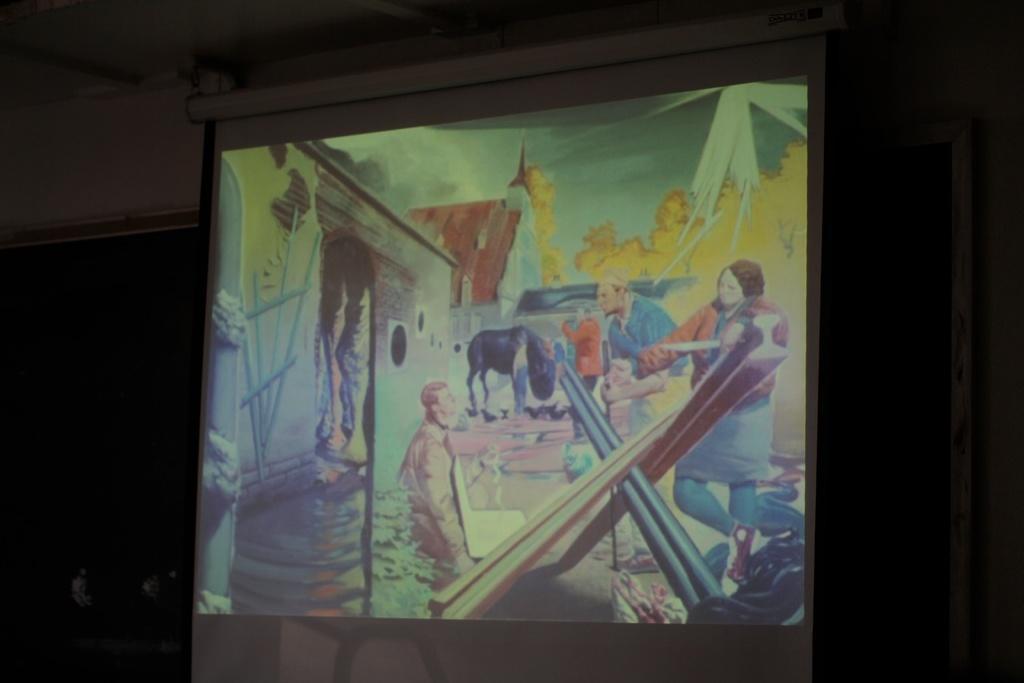Describe this image in one or two sentences. In this picture we can see a projector screen, we can see cartoons of persons, a buildings and fire on the screen, there is a dark background. 